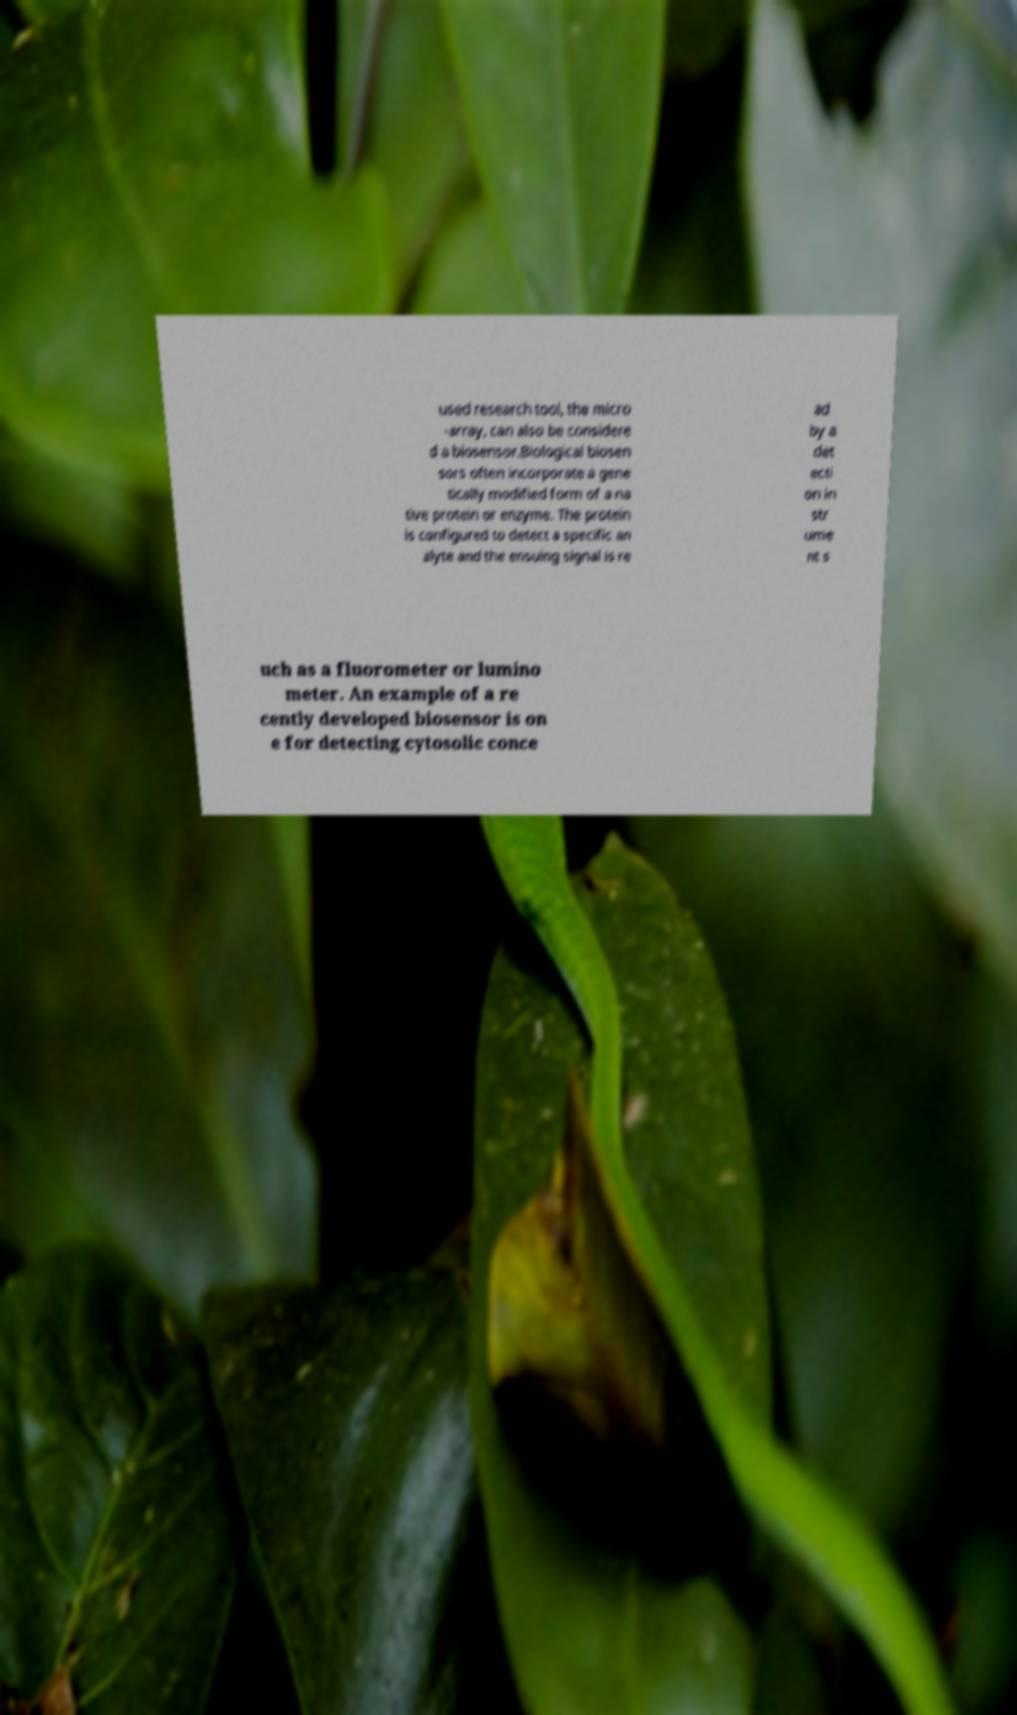Can you accurately transcribe the text from the provided image for me? used research tool, the micro -array, can also be considere d a biosensor.Biological biosen sors often incorporate a gene tically modified form of a na tive protein or enzyme. The protein is configured to detect a specific an alyte and the ensuing signal is re ad by a det ecti on in str ume nt s uch as a fluorometer or lumino meter. An example of a re cently developed biosensor is on e for detecting cytosolic conce 